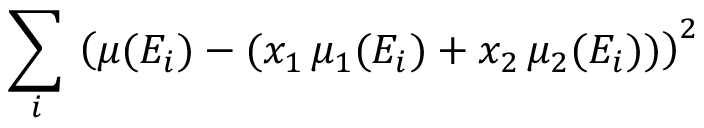<formula> <loc_0><loc_0><loc_500><loc_500>\sum _ { i } \, \left ( \mu ( E _ { i } ) - ( x _ { 1 } \, \mu _ { 1 } ( E _ { i } ) + x _ { 2 } \, \mu _ { 2 } ( E _ { i } ) ) \right ) ^ { 2 }</formula> 